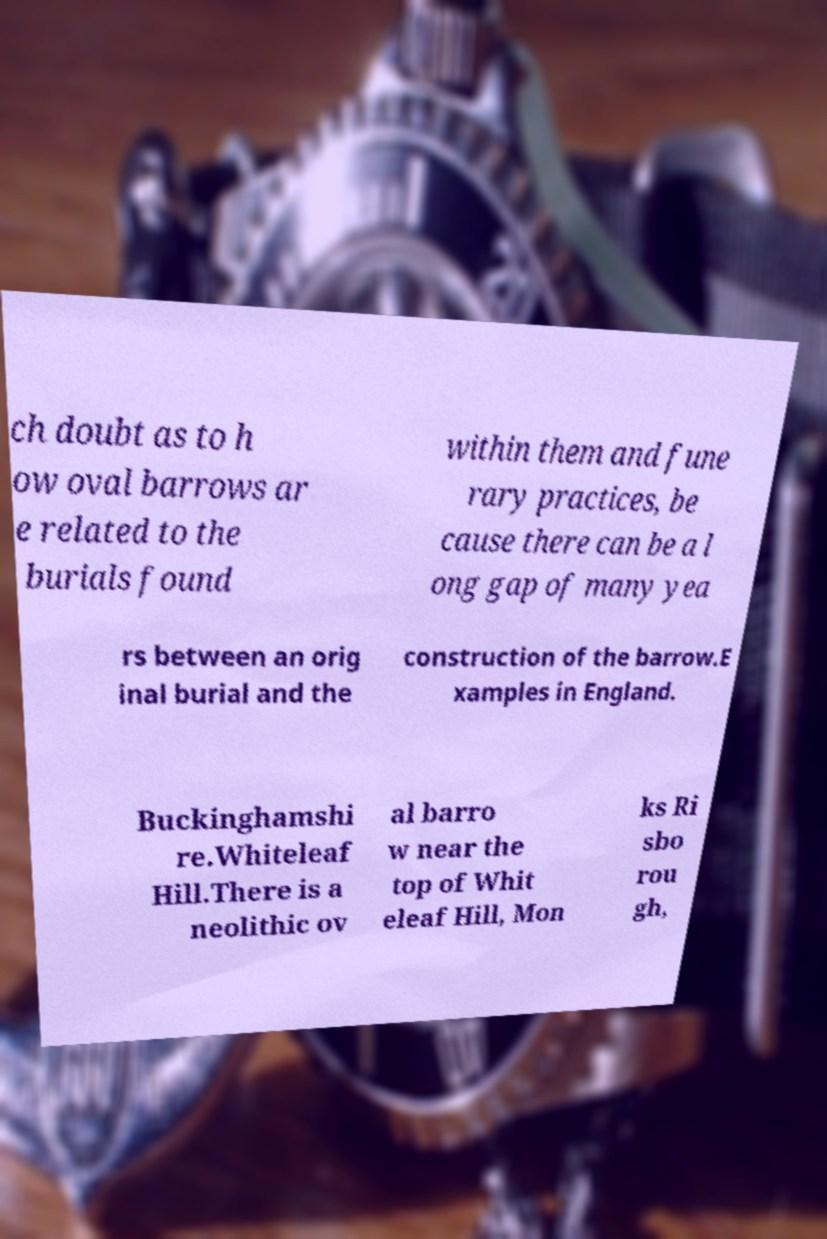I need the written content from this picture converted into text. Can you do that? ch doubt as to h ow oval barrows ar e related to the burials found within them and fune rary practices, be cause there can be a l ong gap of many yea rs between an orig inal burial and the construction of the barrow.E xamples in England. Buckinghamshi re.Whiteleaf Hill.There is a neolithic ov al barro w near the top of Whit eleaf Hill, Mon ks Ri sbo rou gh, 